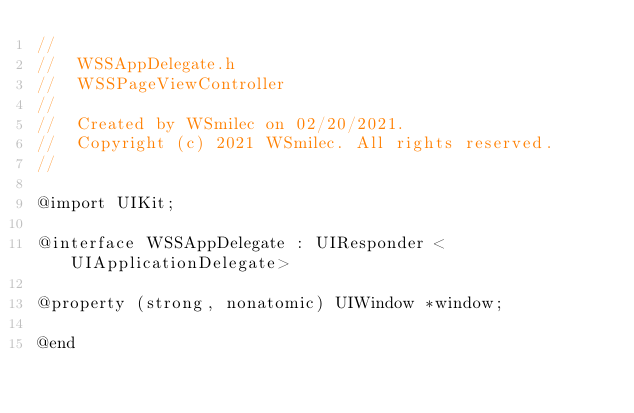<code> <loc_0><loc_0><loc_500><loc_500><_C_>//
//  WSSAppDelegate.h
//  WSSPageViewController
//
//  Created by WSmilec on 02/20/2021.
//  Copyright (c) 2021 WSmilec. All rights reserved.
//

@import UIKit;

@interface WSSAppDelegate : UIResponder <UIApplicationDelegate>

@property (strong, nonatomic) UIWindow *window;

@end
</code> 